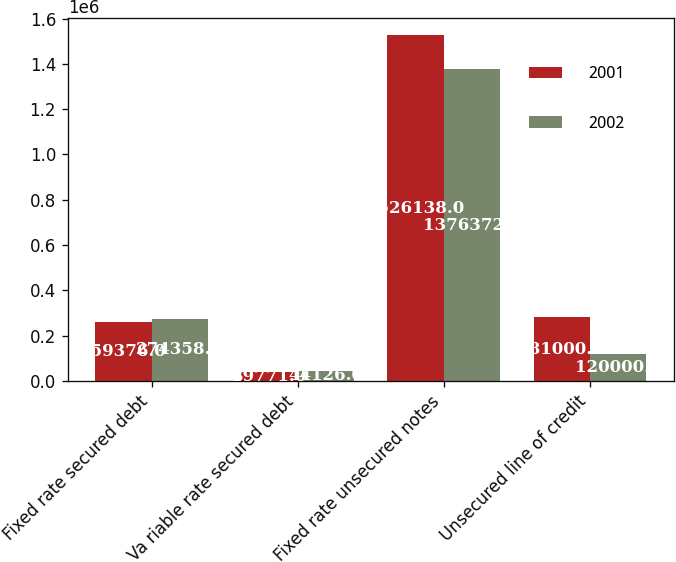<chart> <loc_0><loc_0><loc_500><loc_500><stacked_bar_chart><ecel><fcel>Fixed rate secured debt<fcel>Va riable rate secured debt<fcel>Fixed rate unsecured notes<fcel>Unsecured line of credit<nl><fcel>2001<fcel>259376<fcel>39771<fcel>1.52614e+06<fcel>281000<nl><fcel>2002<fcel>274358<fcel>44126<fcel>1.37637e+06<fcel>120000<nl></chart> 